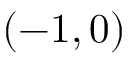<formula> <loc_0><loc_0><loc_500><loc_500>( - 1 , 0 )</formula> 